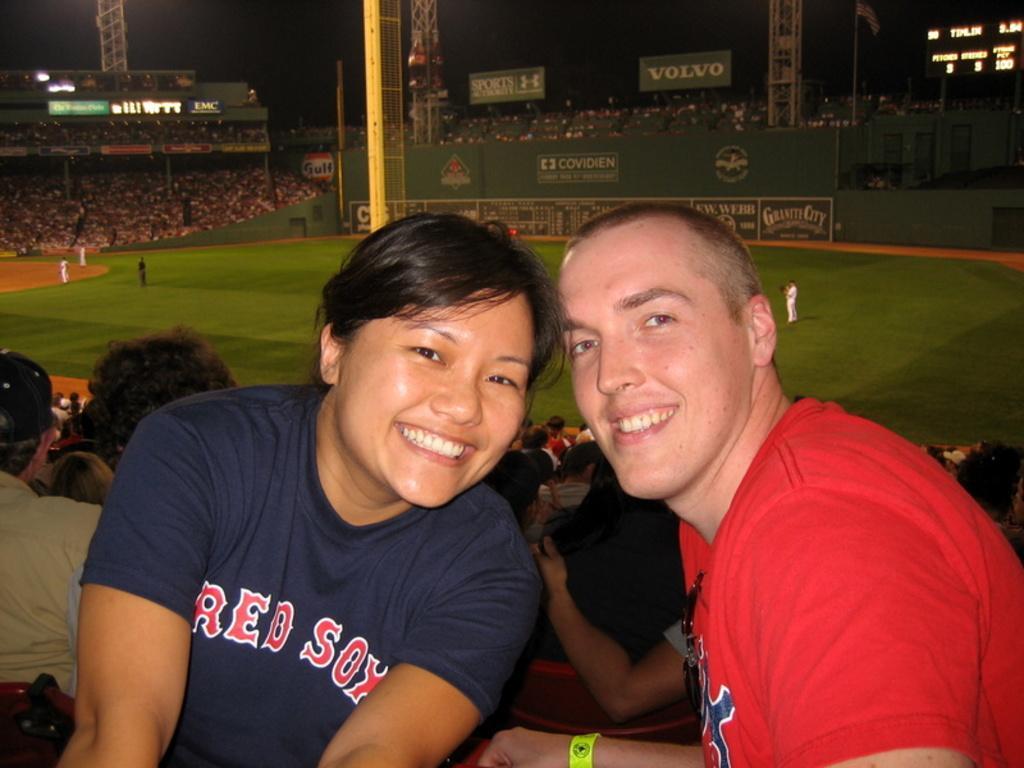Could you give a brief overview of what you see in this image? In this picture we can see there are two people sitting and smiling. Behind the two people there are lots of people in the stadium and some people are standing on the path. Behind the stadium where are poles, the scoreboard and the dark background. 